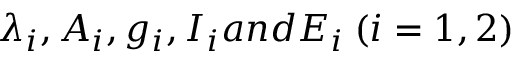Convert formula to latex. <formula><loc_0><loc_0><loc_500><loc_500>\lambda _ { i } , A _ { i } , g _ { i } , I _ { i } a n d E _ { i } \, ( i = 1 , 2 )</formula> 